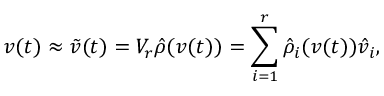Convert formula to latex. <formula><loc_0><loc_0><loc_500><loc_500>v ( t ) \approx { \tilde { v } } ( t ) = V _ { r } { \hat { \rho } } ( v ( t ) ) = \sum _ { i = 1 } ^ { r } { \hat { \rho } } _ { i } ( v ( t ) ) { \hat { v } } _ { i } ,</formula> 